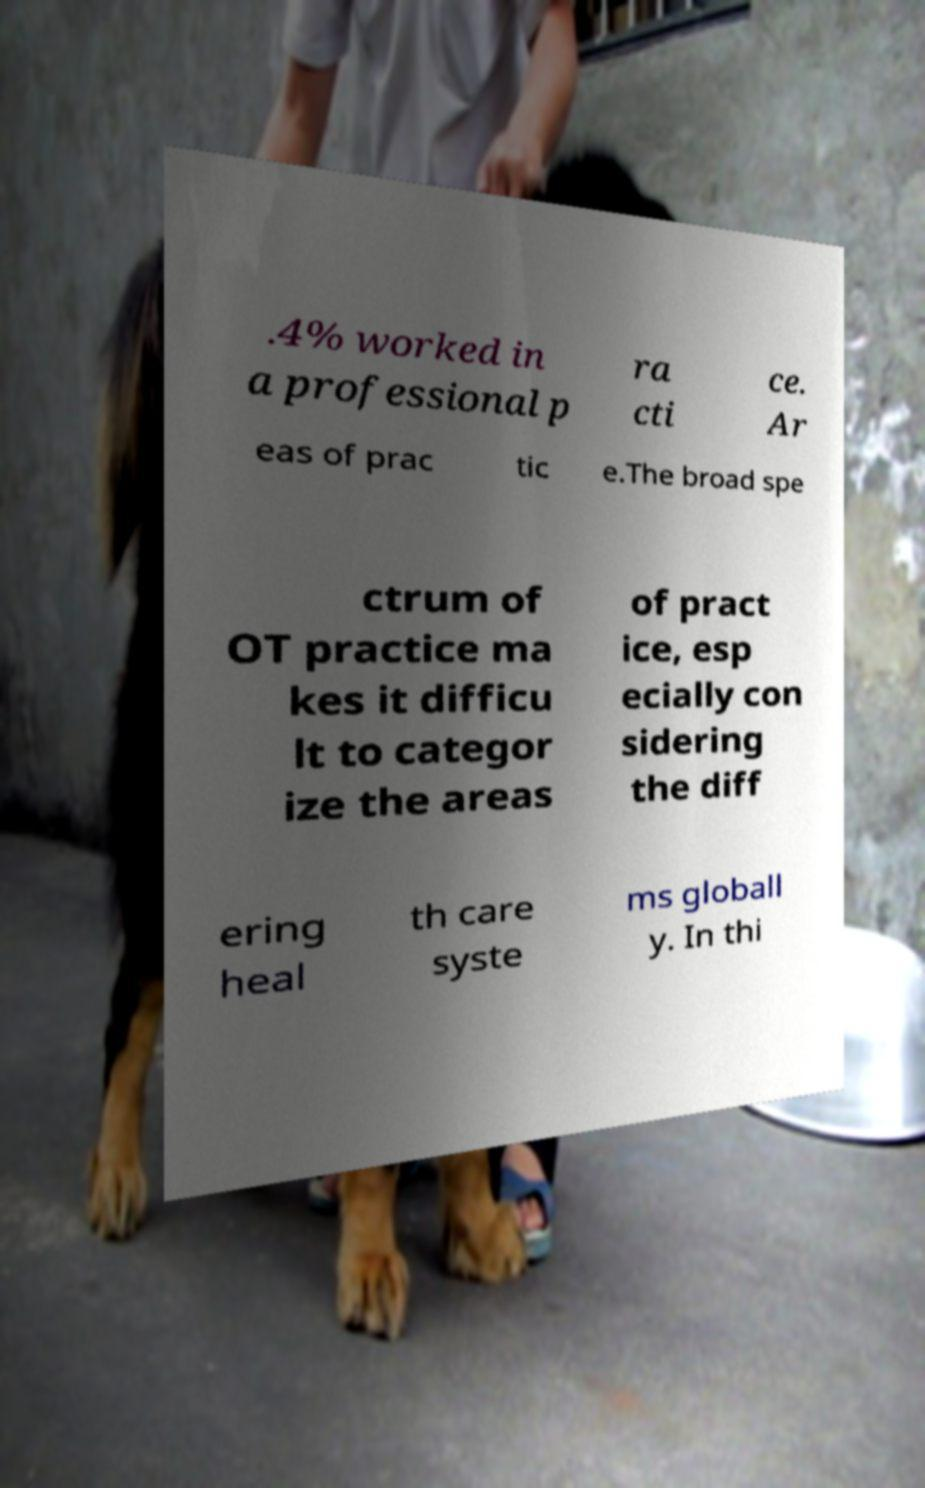For documentation purposes, I need the text within this image transcribed. Could you provide that? .4% worked in a professional p ra cti ce. Ar eas of prac tic e.The broad spe ctrum of OT practice ma kes it difficu lt to categor ize the areas of pract ice, esp ecially con sidering the diff ering heal th care syste ms globall y. In thi 